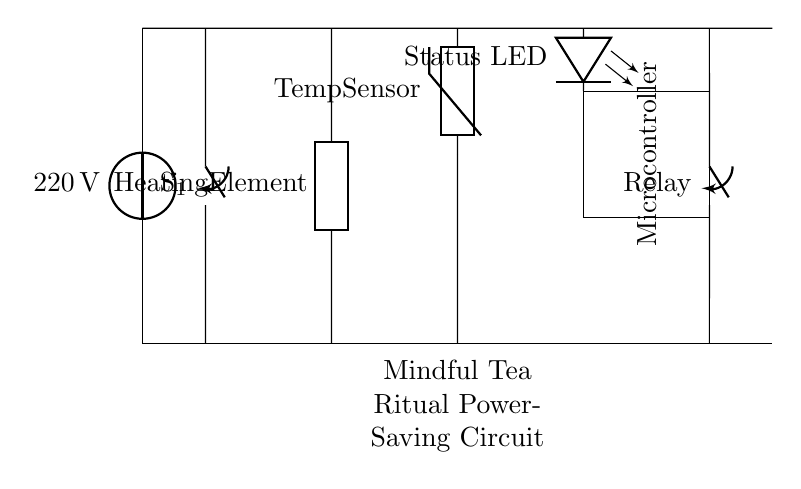What is the main voltage supplied to the circuit? The main voltage supplied to the circuit is indicated by the voltage source symbol at the left. It states 220 volts.
Answer: 220 volts What type of element is used for heating? The heating element is labeled as "Heating Element" in the diagram, indicating it is a generic heating component typically used in devices like electric kettles.
Answer: Heating Element Which component controls the status indication? The status indicator is represented by the LED labeled "Status LED," which shows the operational state of the circuit.
Answer: Status LED What is the role of the temperature sensor in the circuit? The temperature sensor, labeled as "Temp Sensor," monitors the water temperature and aids in controlling the kettle's heating process to prevent overheating.
Answer: Temp Sensor How does the microcontroller influence the kettle's operation? The microcontroller receives input from the temperature sensor and can activate or deactivate the relay, thereby controlling the heating element based on temperature readings for efficient energy use.
Answer: Controls operation What is the purpose of the relay in this circuit? The relay, depicted as a closing switch in the diagram, is used to switch the power to the heating element on and off based on signals from the microcontroller, enabling safe operation of high power loads.
Answer: Switch power 